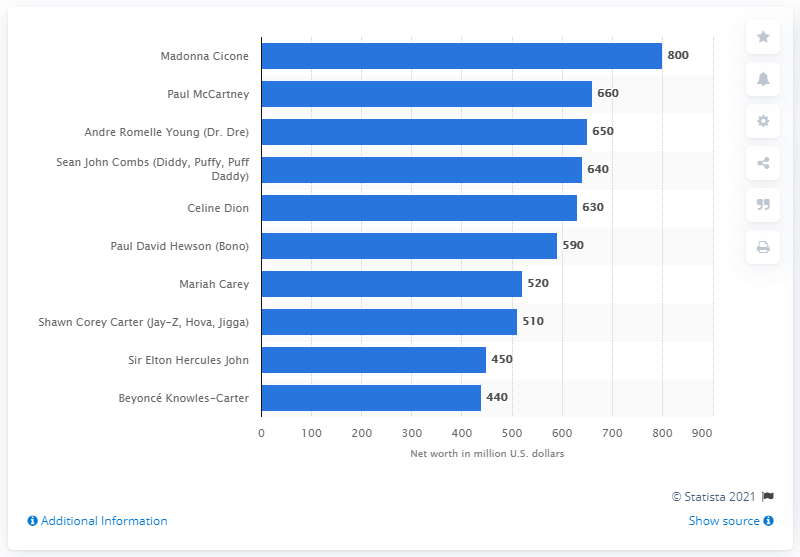Point out several critical features in this image. The value of Madonna's net worth is approximately 800. 